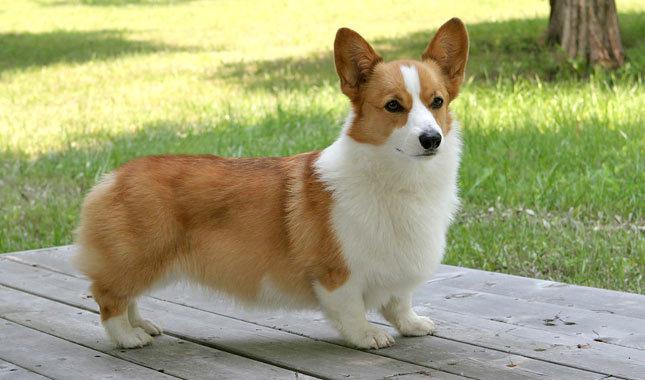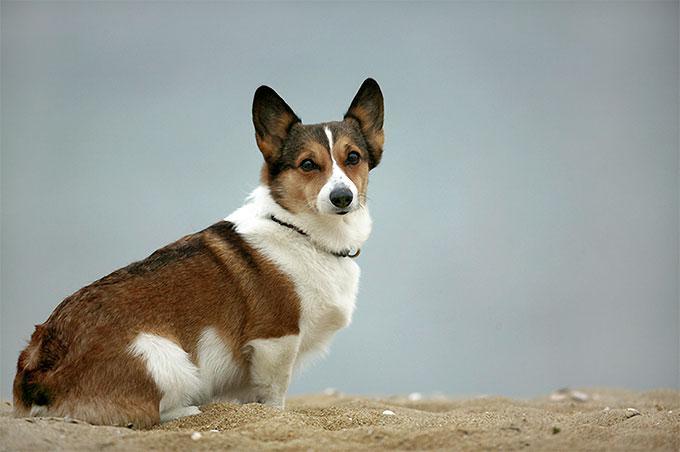The first image is the image on the left, the second image is the image on the right. Analyze the images presented: Is the assertion "There is exactly one dog facing left in the image on the left." valid? Answer yes or no. No. The first image is the image on the left, the second image is the image on the right. Considering the images on both sides, is "One dog is standing on the grass." valid? Answer yes or no. No. The first image is the image on the left, the second image is the image on the right. For the images displayed, is the sentence "The dog on the right is wearing a collar" factually correct? Answer yes or no. Yes. 